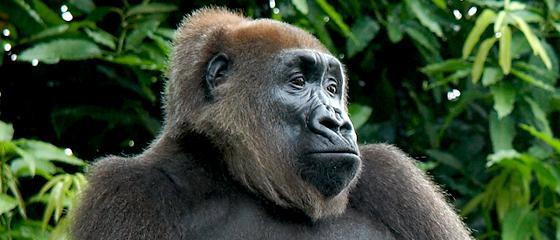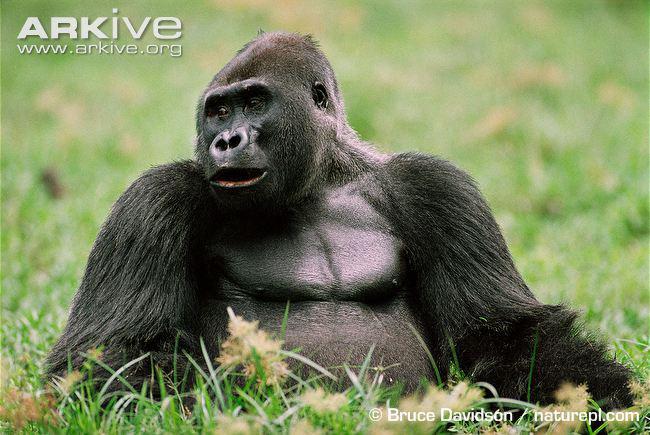The first image is the image on the left, the second image is the image on the right. Analyze the images presented: Is the assertion "A large gorilla is on all fours in one of the images." valid? Answer yes or no. No. 